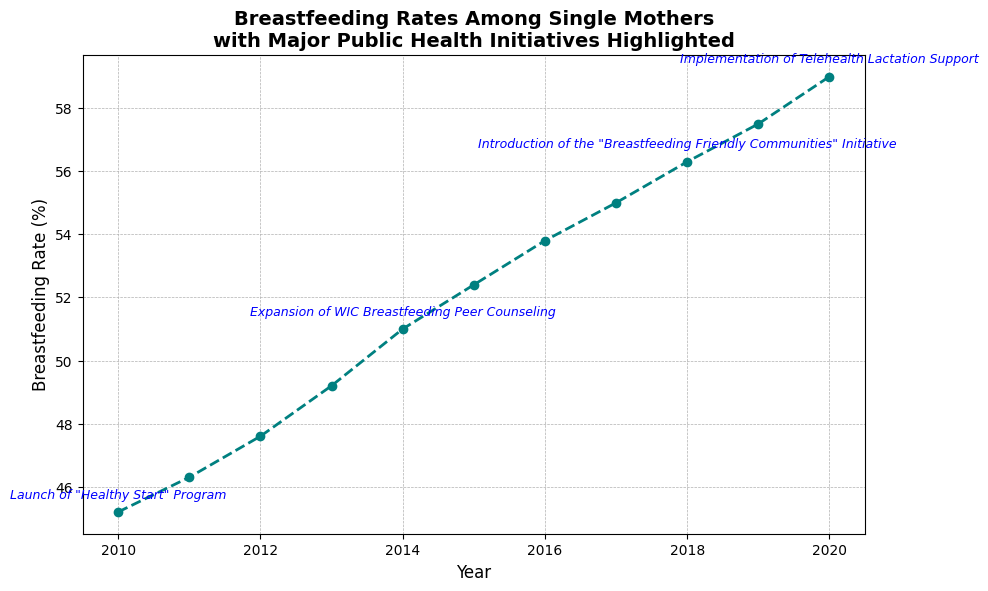What was the breastfeeding rate among single mothers in 2010? The rate is labeled on the y-axis at the position corresponding to the year 2010.
Answer: 45.2% How has the breastfeeding rate changed between 2010 and 2020? Identify the values from 2010 (45.2%) and 2020 (59.0%), then calculate the difference: 59.0% - 45.2% = 13.8%.
Answer: 13.8% increase Which year had the highest breastfeeding rate among the single mothers? The rate for each year is plotted, and the highest point on the line chart corresponds to 2020.
Answer: 2020 What is the average breastfeeding rate from 2010 to 2020? Add the breastfeeding rates for each year from 2010 to 2020, then divide by the number of years (11): (45.2 + 46.3 + 47.6 + 49.2 + 51.0 + 52.4 + 53.8 + 55.0 + 56.3 + 57.5 + 59.0) / 11 ≈ 51.2%.
Answer: 51.2% Between which years did the breastfeeding rate see the most significant increase? The steepest segment in the line chart helps to identify the largest change. The most significant increase is from 2019 to 2020.
Answer: 2019 to 2020 How are the public health initiatives annotated in the chart? They are marked with text labels next to relevant years on the line chart, positioned above the corresponding points.
Answer: Text labels above points Which public health initiative coincided with the year 2014 and what was the breastfeeding rate then? The year 2014 annotation indicates "Expansion of WIC Breastfeeding Peer Counseling," and the breastfeeding rate for that year is marked at 51.0%.
Answer: Expansion of WIC Breastfeeding Peer Counseling, 51.0% What trend can be observed following the implementation of Telehealth Lactation Support in 2020? The breastfeeding rate continued to increase after the implementation of Telehealth Lactation Support in 2020.
Answer: Continued increase Which years have annotated public health initiatives, and what are their respective initiatives? The figure highlights 2010 ("Healthy Start" Program), 2014 (Expansion of WIC Breastfeeding Peer Counseling), 2018 ("Breastfeeding Friendly Communities" Initiative), and 2020 (Telehealth Lactation Support).
Answer: 2010, 2014, 2018, 2020 What is the breastfeeding rate in 2018 and how does it compare to the rate in 2012? The rate was 47.6% in 2012 and increased to 56.3% in 2018. The difference is 56.3% - 47.6% = 8.7%.
Answer: 56.3%, 8.7% higher 